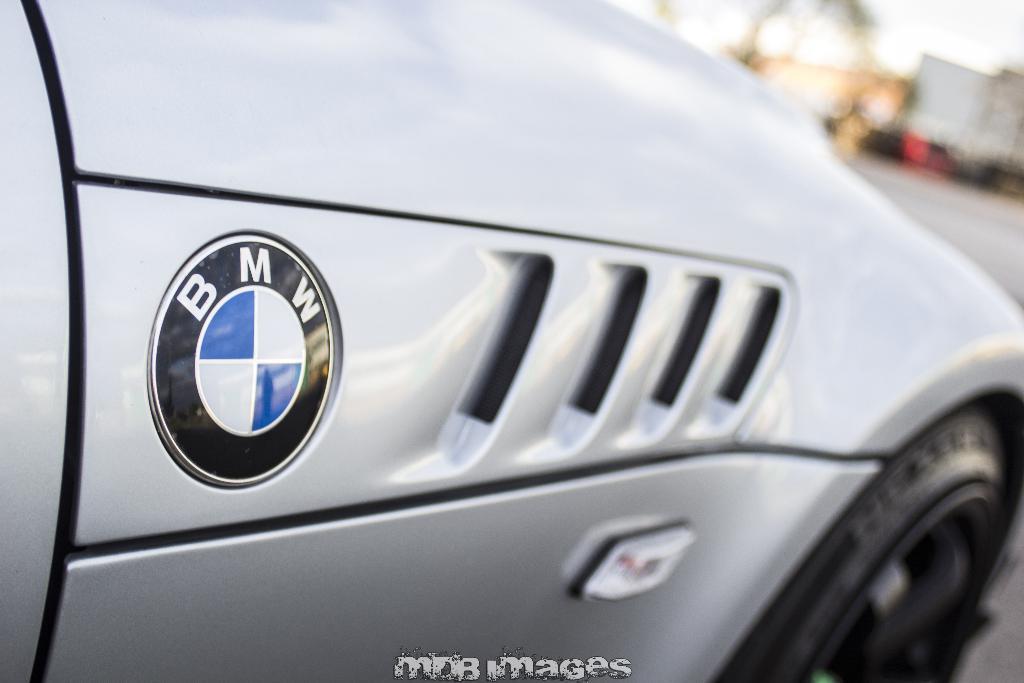How would you summarize this image in a sentence or two? In the picture we can see a side view of the car which is gray in color with a BMW symbol on it and we can also see a tire which is black in color. 